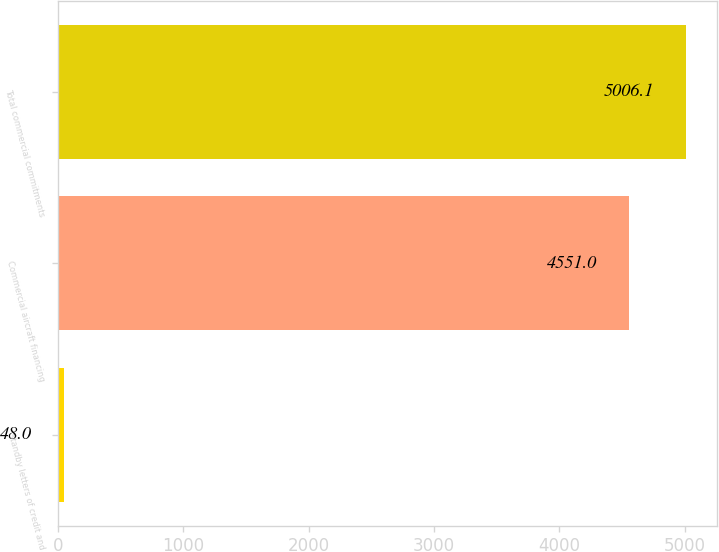Convert chart to OTSL. <chart><loc_0><loc_0><loc_500><loc_500><bar_chart><fcel>Standby letters of credit and<fcel>Commercial aircraft financing<fcel>Total commercial commitments<nl><fcel>48<fcel>4551<fcel>5006.1<nl></chart> 